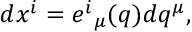Convert formula to latex. <formula><loc_0><loc_0><loc_500><loc_500>d x ^ { i } = e ^ { i _ { \mu } ( q ) d q ^ { \mu } ,</formula> 